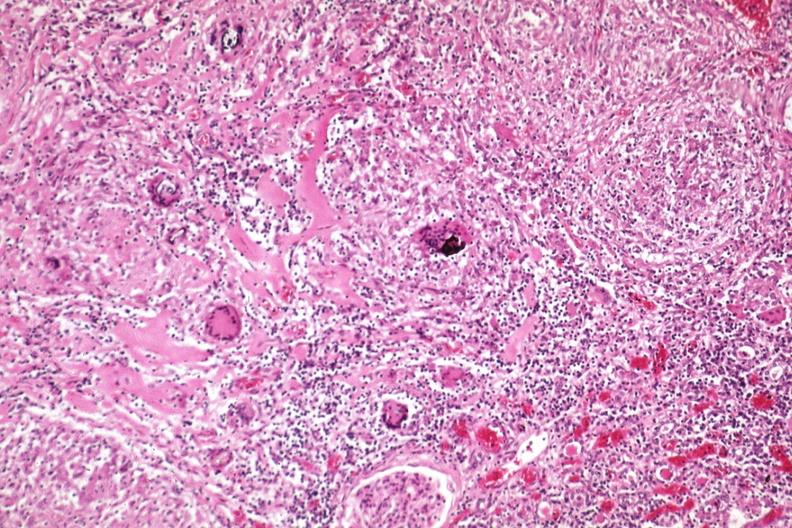what does this image show?
Answer the question using a single word or phrase. Giant cells and fibrosis 